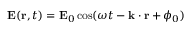Convert formula to latex. <formula><loc_0><loc_0><loc_500><loc_500>E ( r , t ) = E _ { 0 } \cos ( \omega t - k \cdot r + \phi _ { 0 } )</formula> 